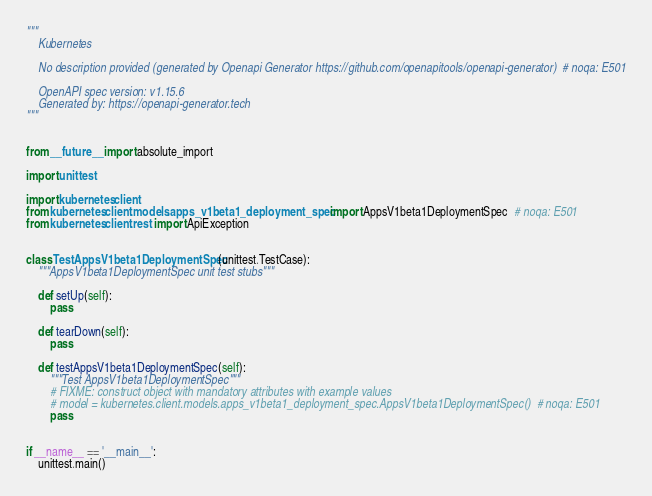Convert code to text. <code><loc_0><loc_0><loc_500><loc_500><_Python_>"""
    Kubernetes

    No description provided (generated by Openapi Generator https://github.com/openapitools/openapi-generator)  # noqa: E501

    OpenAPI spec version: v1.15.6
    Generated by: https://openapi-generator.tech
"""


from __future__ import absolute_import

import unittest

import kubernetes.client
from kubernetes.client.models.apps_v1beta1_deployment_spec import AppsV1beta1DeploymentSpec  # noqa: E501
from kubernetes.client.rest import ApiException


class TestAppsV1beta1DeploymentSpec(unittest.TestCase):
    """AppsV1beta1DeploymentSpec unit test stubs"""

    def setUp(self):
        pass

    def tearDown(self):
        pass

    def testAppsV1beta1DeploymentSpec(self):
        """Test AppsV1beta1DeploymentSpec"""
        # FIXME: construct object with mandatory attributes with example values
        # model = kubernetes.client.models.apps_v1beta1_deployment_spec.AppsV1beta1DeploymentSpec()  # noqa: E501
        pass


if __name__ == '__main__':
    unittest.main()
</code> 